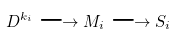Convert formula to latex. <formula><loc_0><loc_0><loc_500><loc_500>D ^ { k _ { i } } \longrightarrow M _ { i } \longrightarrow S _ { i }</formula> 